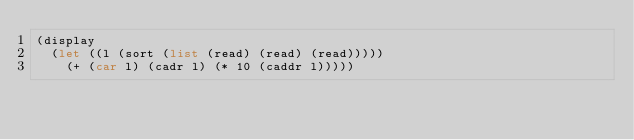Convert code to text. <code><loc_0><loc_0><loc_500><loc_500><_Scheme_>(display
  (let ((l (sort (list (read) (read) (read)))))
    (+ (car l) (cadr l) (* 10 (caddr l)))))
</code> 